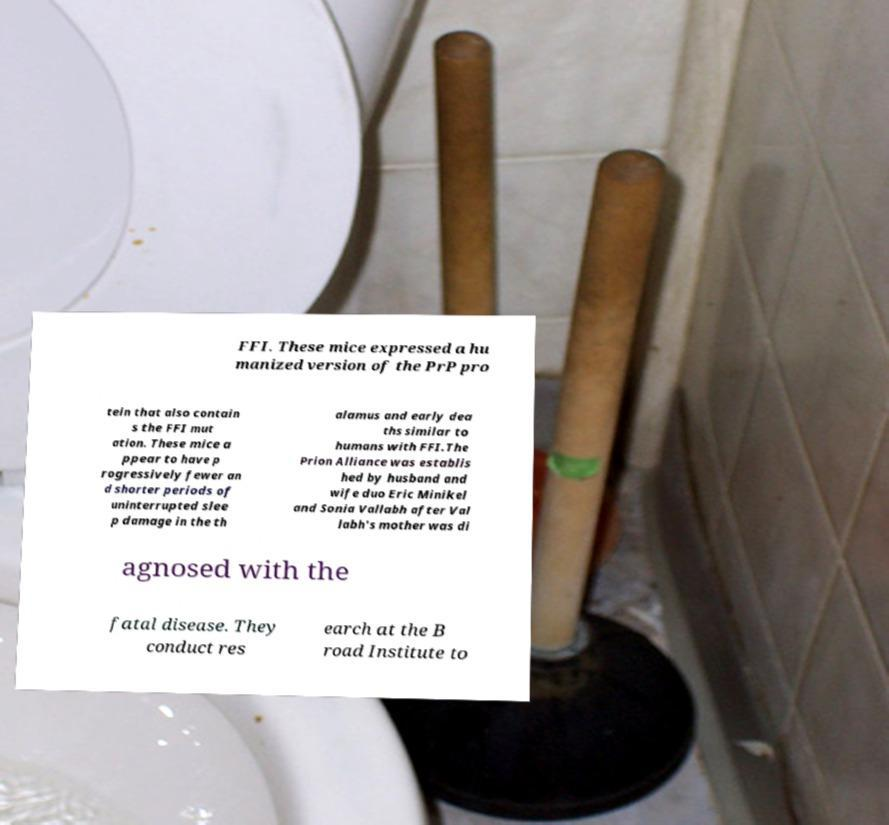Could you extract and type out the text from this image? FFI. These mice expressed a hu manized version of the PrP pro tein that also contain s the FFI mut ation. These mice a ppear to have p rogressively fewer an d shorter periods of uninterrupted slee p damage in the th alamus and early dea ths similar to humans with FFI.The Prion Alliance was establis hed by husband and wife duo Eric Minikel and Sonia Vallabh after Val labh's mother was di agnosed with the fatal disease. They conduct res earch at the B road Institute to 